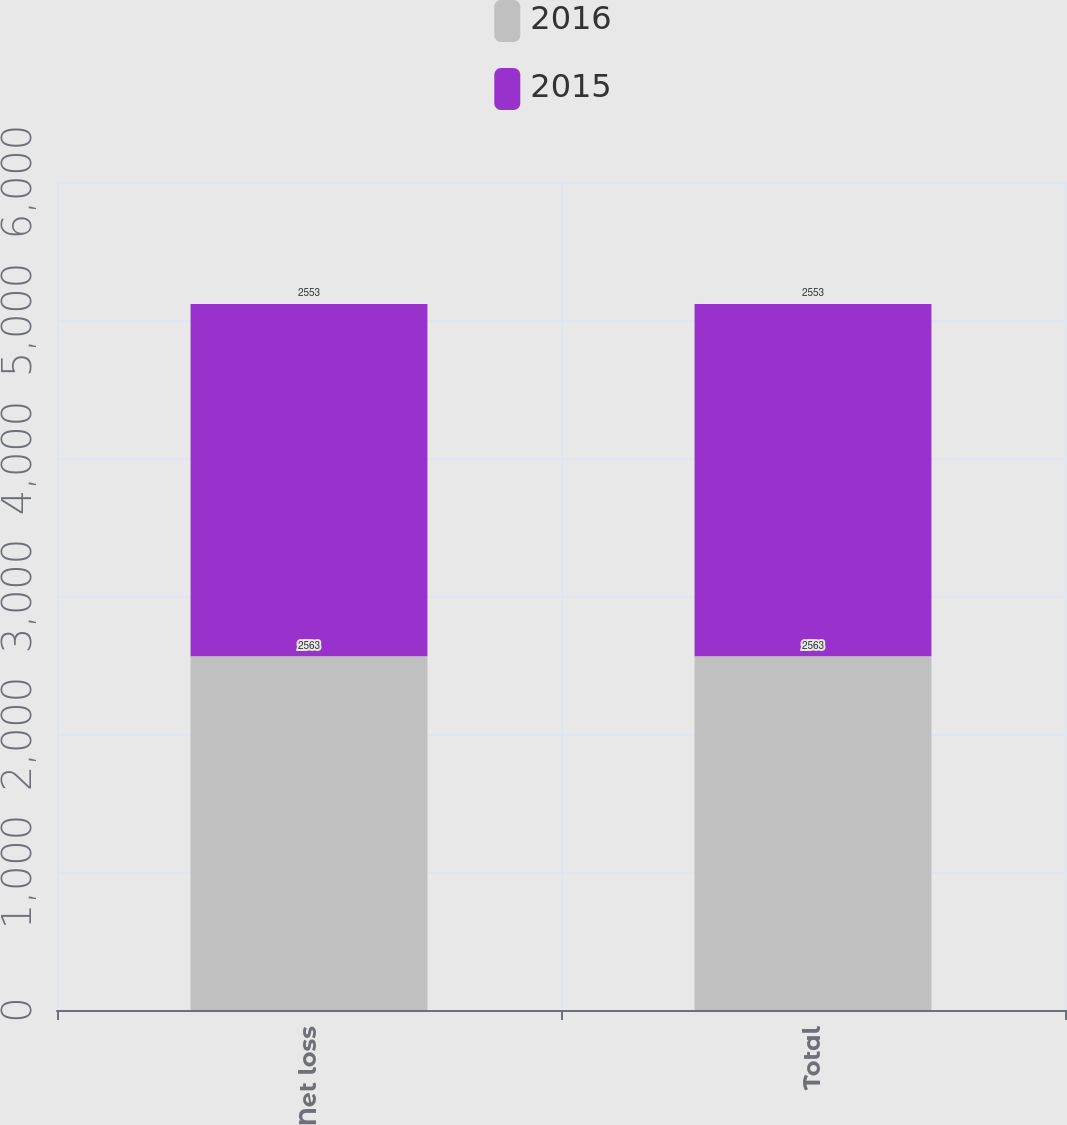Convert chart. <chart><loc_0><loc_0><loc_500><loc_500><stacked_bar_chart><ecel><fcel>Net loss<fcel>Total<nl><fcel>2016<fcel>2563<fcel>2563<nl><fcel>2015<fcel>2553<fcel>2553<nl></chart> 